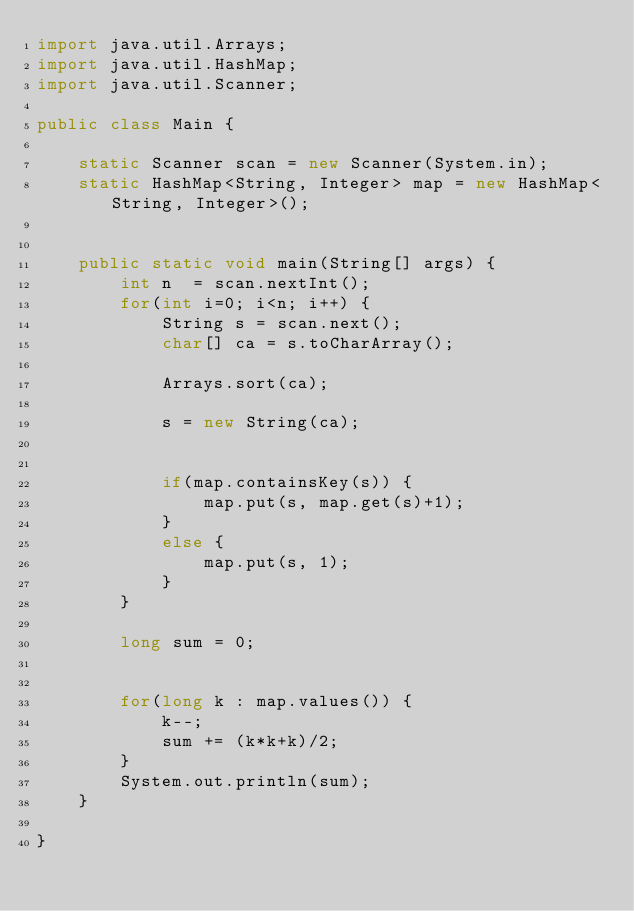<code> <loc_0><loc_0><loc_500><loc_500><_Java_>import java.util.Arrays;
import java.util.HashMap;
import java.util.Scanner;

public class Main {
	
	static Scanner scan = new Scanner(System.in);
	static HashMap<String, Integer> map = new HashMap<String, Integer>();
	
	
	public static void main(String[] args) {
		int n  = scan.nextInt();
		for(int i=0; i<n; i++) {
			String s = scan.next();
			char[] ca = s.toCharArray();
			
			Arrays.sort(ca);
			
			s = new String(ca);
			
			
			if(map.containsKey(s)) {
				map.put(s, map.get(s)+1);
			}
			else {
				map.put(s, 1);
			}
		}
		
		long sum = 0;
		
		
		for(long k : map.values()) {
			k--;
			sum += (k*k+k)/2;
		}
		System.out.println(sum);
	}

}
</code> 